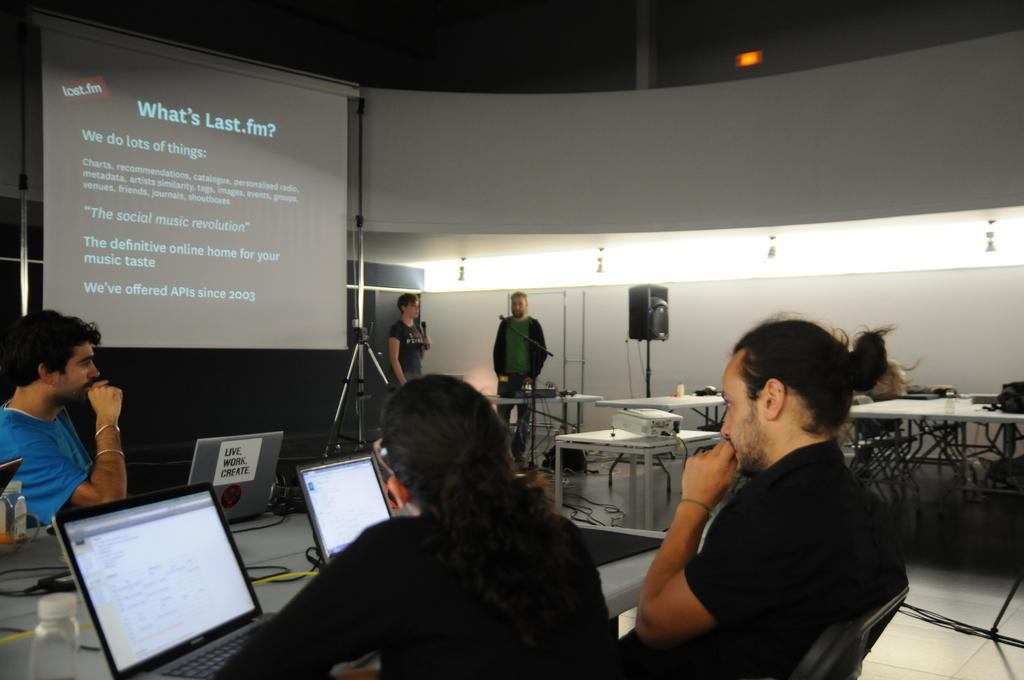<image>
Give a short and clear explanation of the subsequent image. People watching something on the screen that says "What's Last.fm?". 